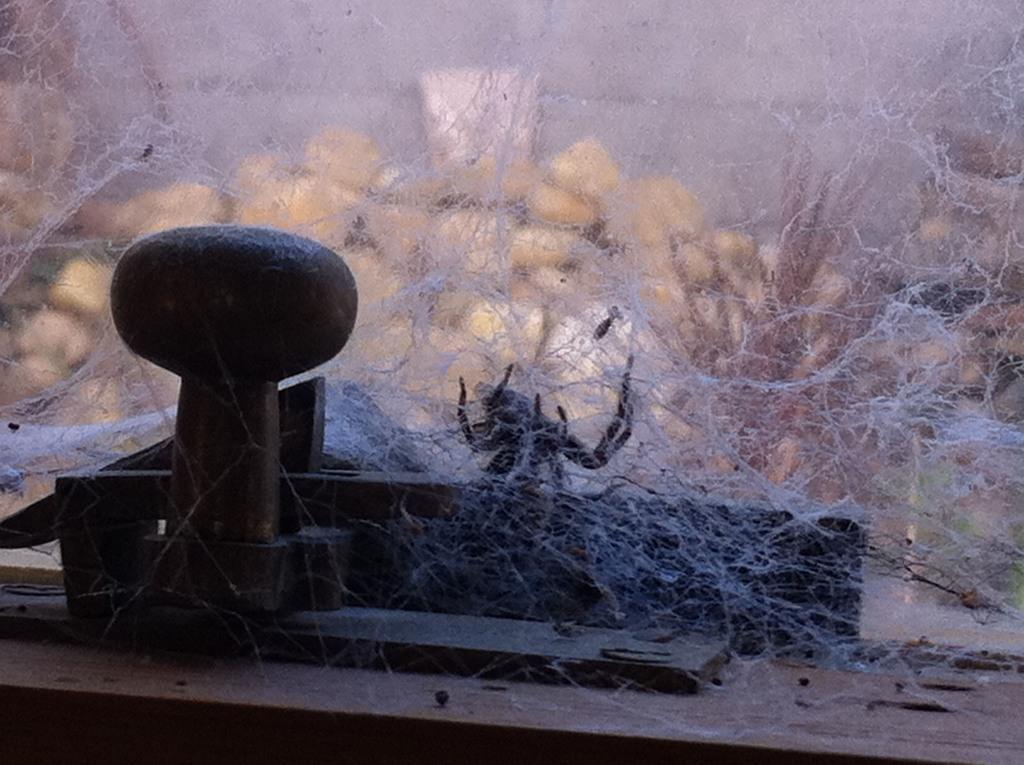Could you give a brief overview of what you see in this image? In this picture I can see a spider and its web in the middle, on the left side it looks like an iron thing. 